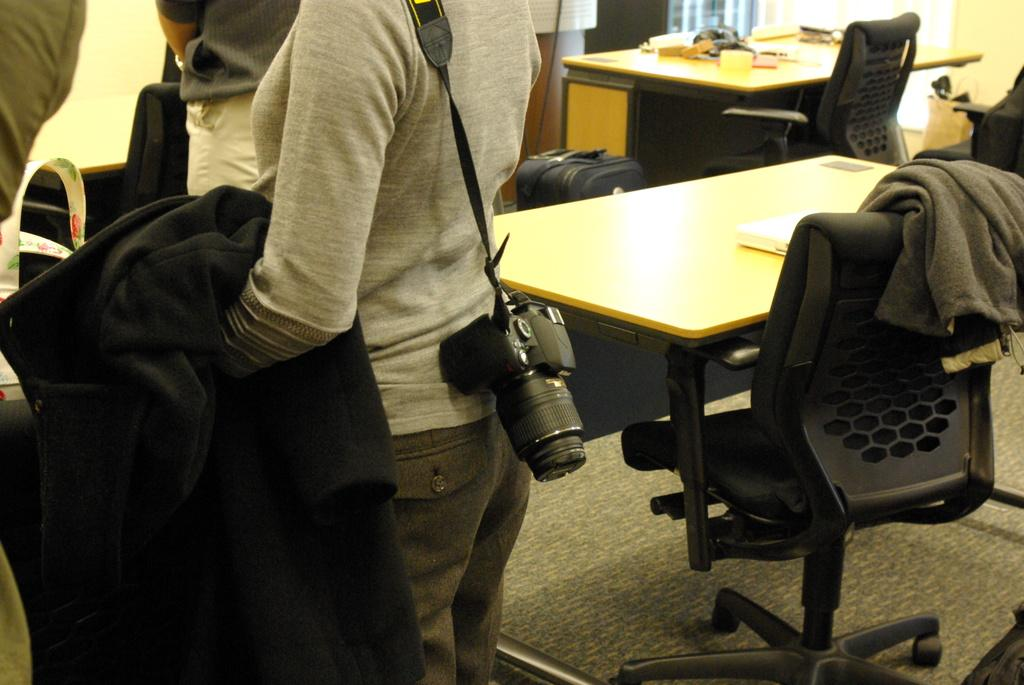What type of furniture is present in the image? There are chairs and a table in the image. What is the person holding in the image? The person is holding a jacket in the image. What is the person wearing in the image? The person is wearing a camera in the image. What type of personal belongings can be seen in the image? There is luggage and a camera in the image. What is on the table in the image? There are things on the table in the image. Can you tell me how many railway tracks are visible in the image? There are no railway tracks present in the image. Is there a guide standing next to the person in the image? There is no guide present in the image. 